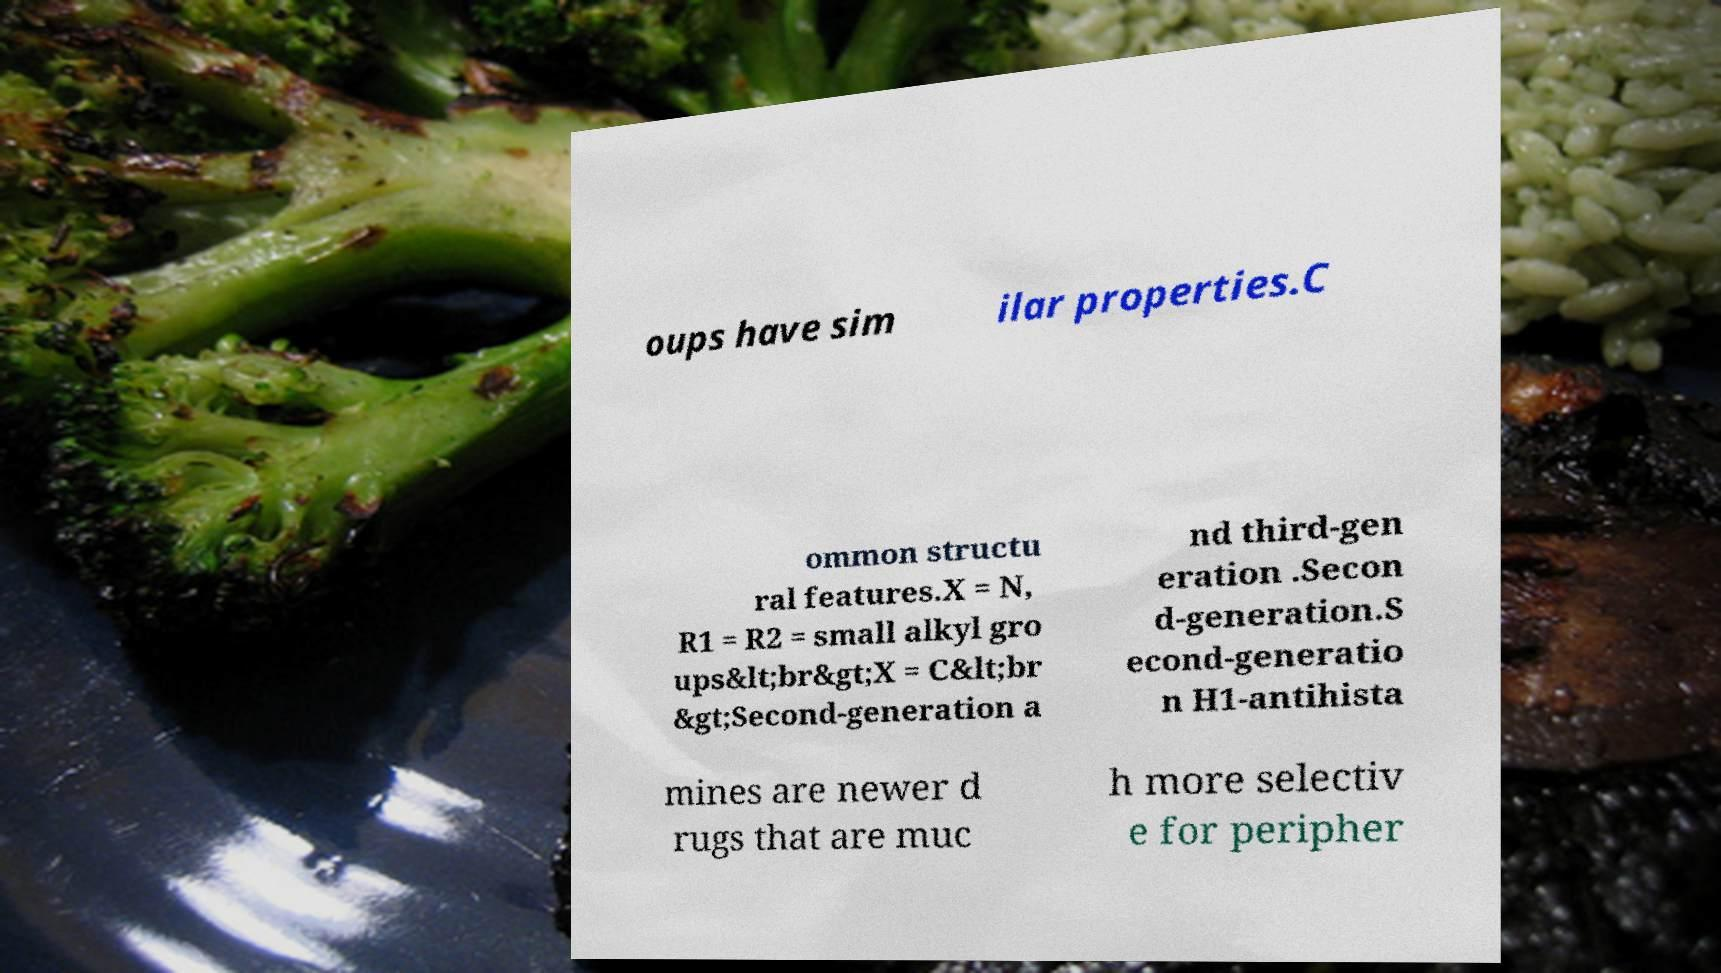For documentation purposes, I need the text within this image transcribed. Could you provide that? oups have sim ilar properties.C ommon structu ral features.X = N, R1 = R2 = small alkyl gro ups&lt;br&gt;X = C&lt;br &gt;Second-generation a nd third-gen eration .Secon d-generation.S econd-generatio n H1-antihista mines are newer d rugs that are muc h more selectiv e for peripher 